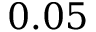<formula> <loc_0><loc_0><loc_500><loc_500>0 . 0 5</formula> 